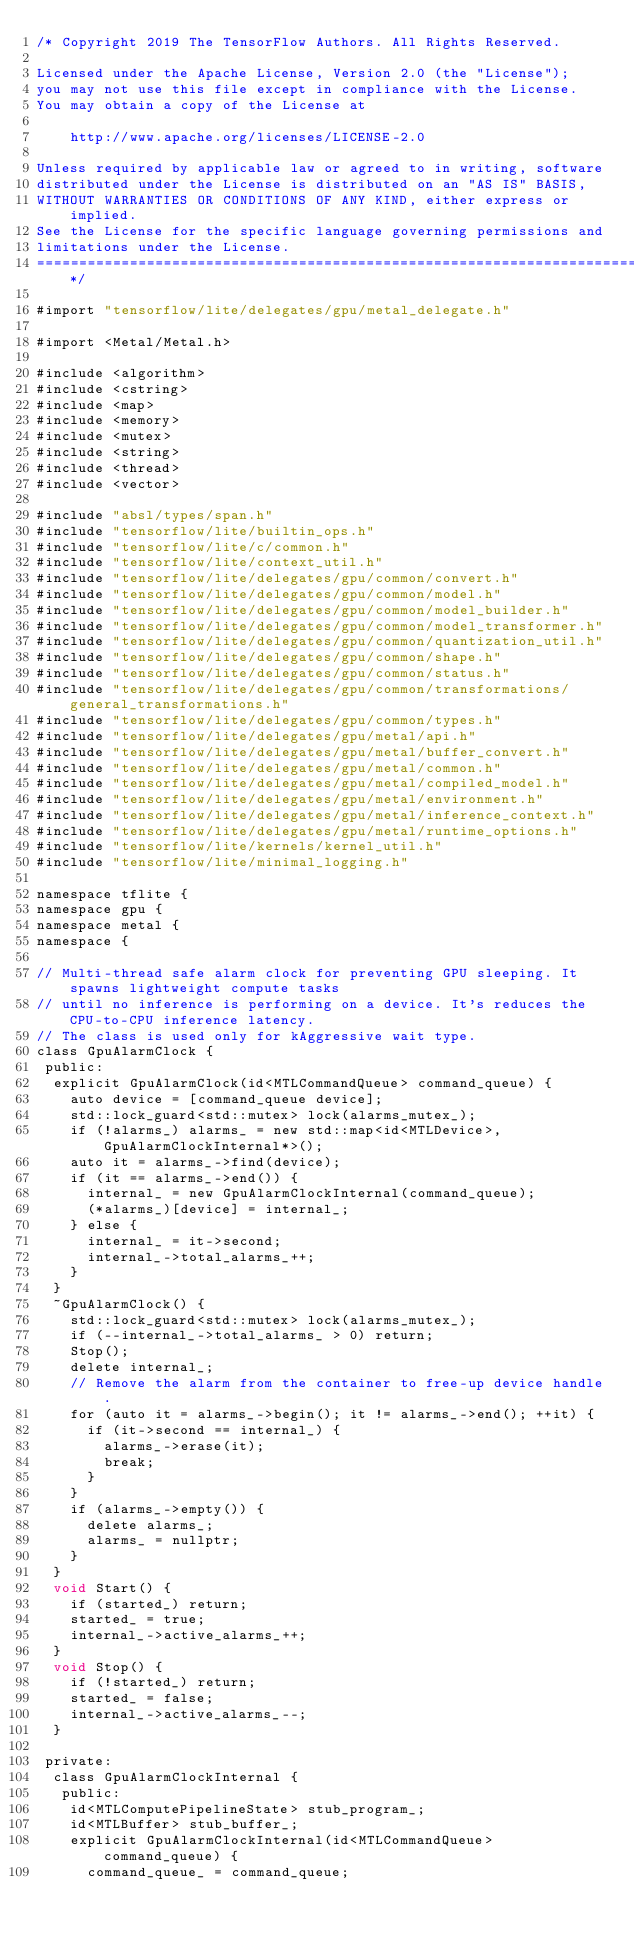<code> <loc_0><loc_0><loc_500><loc_500><_ObjectiveC_>/* Copyright 2019 The TensorFlow Authors. All Rights Reserved.

Licensed under the Apache License, Version 2.0 (the "License");
you may not use this file except in compliance with the License.
You may obtain a copy of the License at

    http://www.apache.org/licenses/LICENSE-2.0

Unless required by applicable law or agreed to in writing, software
distributed under the License is distributed on an "AS IS" BASIS,
WITHOUT WARRANTIES OR CONDITIONS OF ANY KIND, either express or implied.
See the License for the specific language governing permissions and
limitations under the License.
==============================================================================*/

#import "tensorflow/lite/delegates/gpu/metal_delegate.h"

#import <Metal/Metal.h>

#include <algorithm>
#include <cstring>
#include <map>
#include <memory>
#include <mutex>
#include <string>
#include <thread>
#include <vector>

#include "absl/types/span.h"
#include "tensorflow/lite/builtin_ops.h"
#include "tensorflow/lite/c/common.h"
#include "tensorflow/lite/context_util.h"
#include "tensorflow/lite/delegates/gpu/common/convert.h"
#include "tensorflow/lite/delegates/gpu/common/model.h"
#include "tensorflow/lite/delegates/gpu/common/model_builder.h"
#include "tensorflow/lite/delegates/gpu/common/model_transformer.h"
#include "tensorflow/lite/delegates/gpu/common/quantization_util.h"
#include "tensorflow/lite/delegates/gpu/common/shape.h"
#include "tensorflow/lite/delegates/gpu/common/status.h"
#include "tensorflow/lite/delegates/gpu/common/transformations/general_transformations.h"
#include "tensorflow/lite/delegates/gpu/common/types.h"
#include "tensorflow/lite/delegates/gpu/metal/api.h"
#include "tensorflow/lite/delegates/gpu/metal/buffer_convert.h"
#include "tensorflow/lite/delegates/gpu/metal/common.h"
#include "tensorflow/lite/delegates/gpu/metal/compiled_model.h"
#include "tensorflow/lite/delegates/gpu/metal/environment.h"
#include "tensorflow/lite/delegates/gpu/metal/inference_context.h"
#include "tensorflow/lite/delegates/gpu/metal/runtime_options.h"
#include "tensorflow/lite/kernels/kernel_util.h"
#include "tensorflow/lite/minimal_logging.h"

namespace tflite {
namespace gpu {
namespace metal {
namespace {

// Multi-thread safe alarm clock for preventing GPU sleeping. It spawns lightweight compute tasks
// until no inference is performing on a device. It's reduces the CPU-to-CPU inference latency.
// The class is used only for kAggressive wait type.
class GpuAlarmClock {
 public:
  explicit GpuAlarmClock(id<MTLCommandQueue> command_queue) {
    auto device = [command_queue device];
    std::lock_guard<std::mutex> lock(alarms_mutex_);
    if (!alarms_) alarms_ = new std::map<id<MTLDevice>, GpuAlarmClockInternal*>();
    auto it = alarms_->find(device);
    if (it == alarms_->end()) {
      internal_ = new GpuAlarmClockInternal(command_queue);
      (*alarms_)[device] = internal_;
    } else {
      internal_ = it->second;
      internal_->total_alarms_++;
    }
  }
  ~GpuAlarmClock() {
    std::lock_guard<std::mutex> lock(alarms_mutex_);
    if (--internal_->total_alarms_ > 0) return;
    Stop();
    delete internal_;
    // Remove the alarm from the container to free-up device handle.
    for (auto it = alarms_->begin(); it != alarms_->end(); ++it) {
      if (it->second == internal_) {
        alarms_->erase(it);
        break;
      }
    }
    if (alarms_->empty()) {
      delete alarms_;
      alarms_ = nullptr;
    }
  }
  void Start() {
    if (started_) return;
    started_ = true;
    internal_->active_alarms_++;
  }
  void Stop() {
    if (!started_) return;
    started_ = false;
    internal_->active_alarms_--;
  }

 private:
  class GpuAlarmClockInternal {
   public:
    id<MTLComputePipelineState> stub_program_;
    id<MTLBuffer> stub_buffer_;
    explicit GpuAlarmClockInternal(id<MTLCommandQueue> command_queue) {
      command_queue_ = command_queue;</code> 